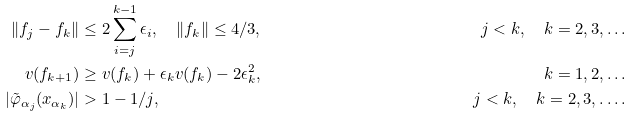<formula> <loc_0><loc_0><loc_500><loc_500>\| f _ { j } - f _ { k } \| & \leq 2 \sum _ { i = j } ^ { k - 1 } \epsilon _ { i } , \quad \| f _ { k } \| \leq 4 / 3 , & j < k , \quad k = 2 , 3 , \dots \\ v ( f _ { k + 1 } ) & \geq v ( f _ { k } ) + \epsilon _ { k } v ( f _ { k } ) - 2 \epsilon _ { k } ^ { 2 } , & k = 1 , 2 , \dots \\ | \tilde { \varphi } _ { \alpha _ { j } } ( x _ { \alpha _ { k } } ) | & > 1 - 1 / j , & j < k , \quad k = 2 , 3 , \dots .</formula> 